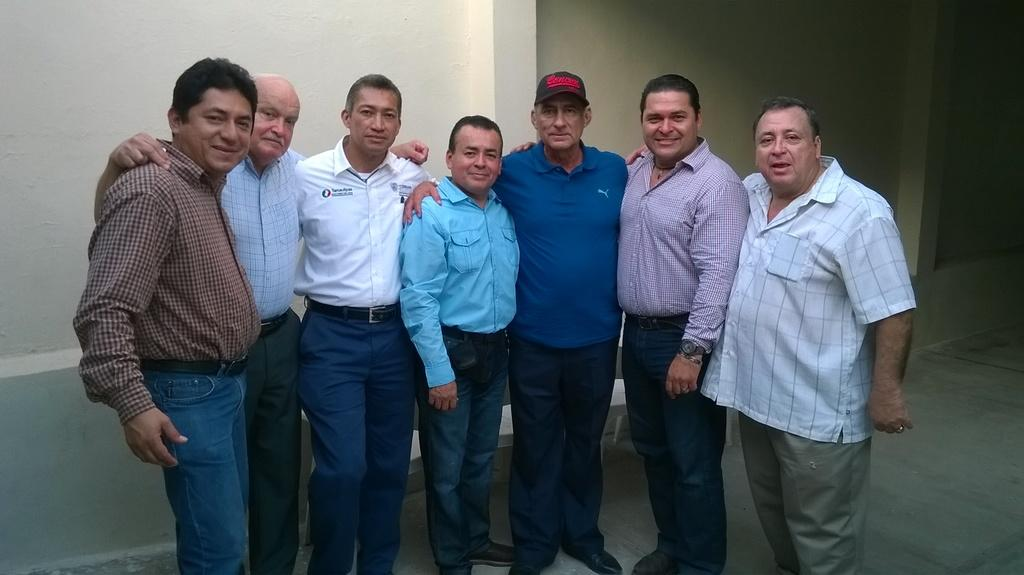What is happening in the image? There are people standing in the image. Can you describe the clothing of one of the individuals? A man is wearing a cap in the image. What type of seating is present in the image? There is a bench in the image. What can be seen in the background of the image? There is a wall in the background of the image. What organization does the maid belong to in the image? There is no maid present in the image, so it is not possible to determine which organization they might belong to. 